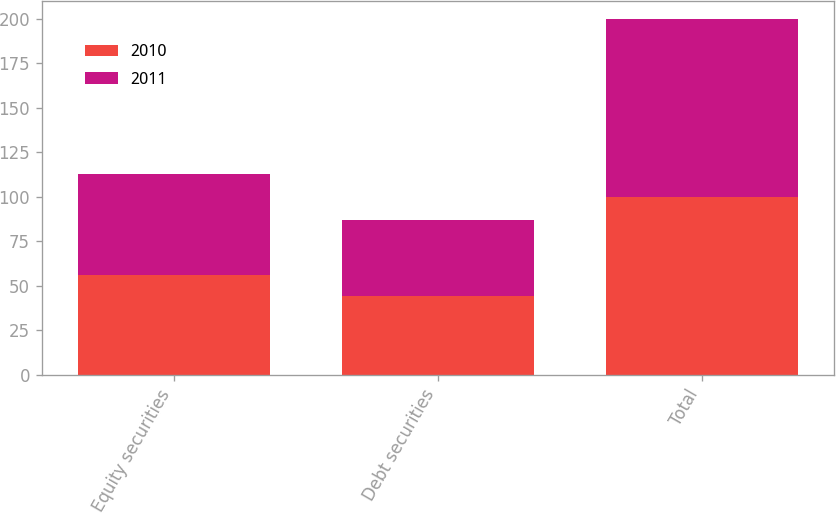<chart> <loc_0><loc_0><loc_500><loc_500><stacked_bar_chart><ecel><fcel>Equity securities<fcel>Debt securities<fcel>Total<nl><fcel>2010<fcel>56<fcel>44<fcel>100<nl><fcel>2011<fcel>57<fcel>43<fcel>100<nl></chart> 